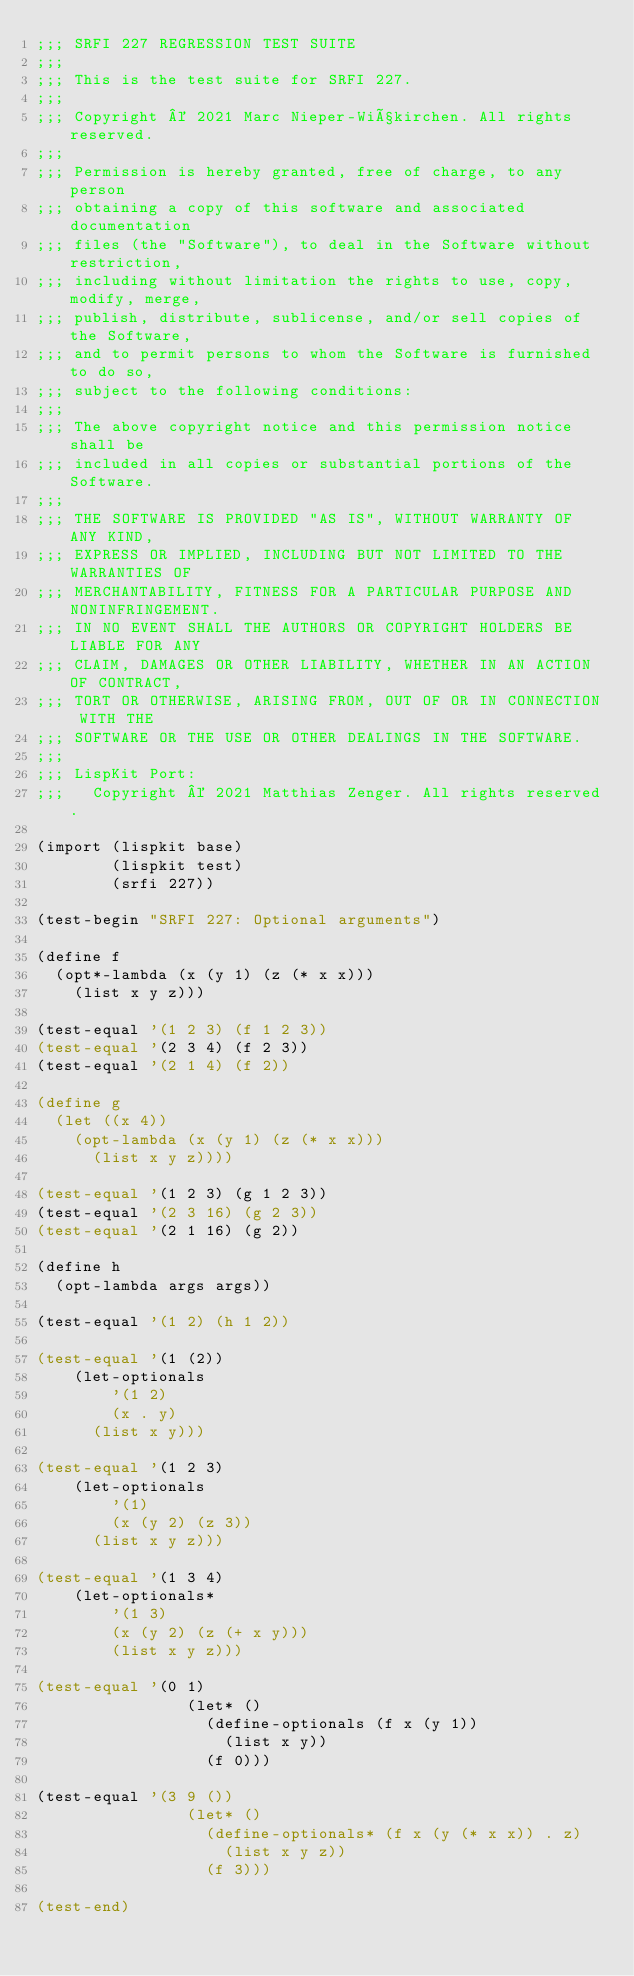<code> <loc_0><loc_0><loc_500><loc_500><_Scheme_>;;; SRFI 227 REGRESSION TEST SUITE
;;;
;;; This is the test suite for SRFI 227.
;;;
;;; Copyright © 2021 Marc Nieper-Wißkirchen. All rights reserved.
;;;
;;; Permission is hereby granted, free of charge, to any person
;;; obtaining a copy of this software and associated documentation
;;; files (the "Software"), to deal in the Software without restriction,
;;; including without limitation the rights to use, copy, modify, merge,
;;; publish, distribute, sublicense, and/or sell copies of the Software,
;;; and to permit persons to whom the Software is furnished to do so,
;;; subject to the following conditions:
;;;
;;; The above copyright notice and this permission notice shall be
;;; included in all copies or substantial portions of the Software.
;;;
;;; THE SOFTWARE IS PROVIDED "AS IS", WITHOUT WARRANTY OF ANY KIND,
;;; EXPRESS OR IMPLIED, INCLUDING BUT NOT LIMITED TO THE WARRANTIES OF
;;; MERCHANTABILITY, FITNESS FOR A PARTICULAR PURPOSE AND NONINFRINGEMENT.
;;; IN NO EVENT SHALL THE AUTHORS OR COPYRIGHT HOLDERS BE LIABLE FOR ANY
;;; CLAIM, DAMAGES OR OTHER LIABILITY, WHETHER IN AN ACTION OF CONTRACT,
;;; TORT OR OTHERWISE, ARISING FROM, OUT OF OR IN CONNECTION WITH THE
;;; SOFTWARE OR THE USE OR OTHER DEALINGS IN THE SOFTWARE.
;;;
;;; LispKit Port:
;;;   Copyright © 2021 Matthias Zenger. All rights reserved.

(import (lispkit base)
        (lispkit test)
        (srfi 227))

(test-begin "SRFI 227: Optional arguments")

(define f
  (opt*-lambda (x (y 1) (z (* x x)))
    (list x y z)))

(test-equal '(1 2 3) (f 1 2 3))
(test-equal '(2 3 4) (f 2 3))
(test-equal '(2 1 4) (f 2))

(define g
  (let ((x 4))
    (opt-lambda (x (y 1) (z (* x x)))
      (list x y z))))

(test-equal '(1 2 3) (g 1 2 3))
(test-equal '(2 3 16) (g 2 3))
(test-equal '(2 1 16) (g 2))

(define h
  (opt-lambda args args))

(test-equal '(1 2) (h 1 2))

(test-equal '(1 (2))
    (let-optionals
        '(1 2)
        (x . y)
      (list x y)))

(test-equal '(1 2 3)
    (let-optionals
        '(1)
        (x (y 2) (z 3))
      (list x y z)))

(test-equal '(1 3 4)
    (let-optionals*
        '(1 3)
        (x (y 2) (z (+ x y)))
        (list x y z)))

(test-equal '(0 1)
                (let* ()
                  (define-optionals (f x (y 1))
                    (list x y))
                  (f 0)))

(test-equal '(3 9 ())
                (let* ()
                  (define-optionals* (f x (y (* x x)) . z)
                    (list x y z))
                  (f 3)))

(test-end)
</code> 